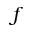Convert formula to latex. <formula><loc_0><loc_0><loc_500><loc_500>f</formula> 